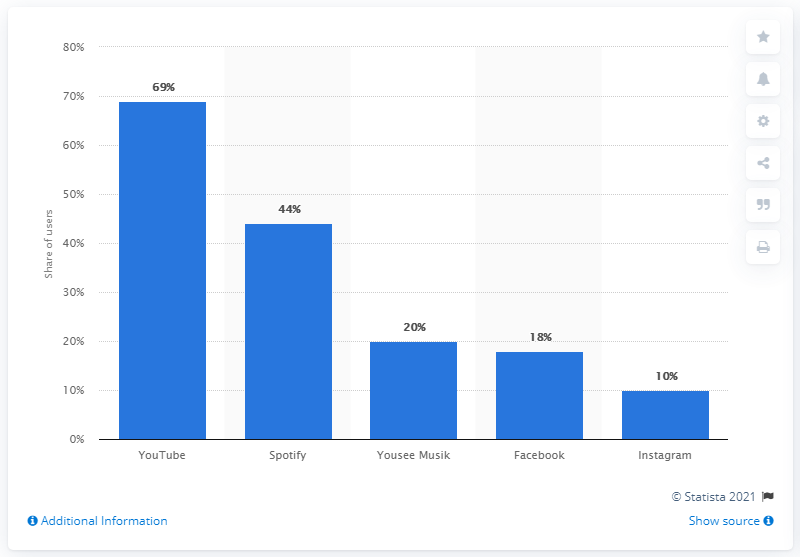What is the most used digital music service in Denmark?
 YouTube 